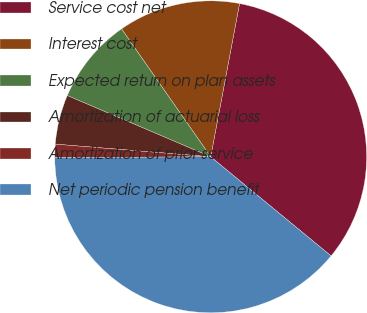Convert chart. <chart><loc_0><loc_0><loc_500><loc_500><pie_chart><fcel>Service cost net<fcel>Interest cost<fcel>Expected return on plan assets<fcel>Amortization of actuarial loss<fcel>Amortization of prior service<fcel>Net periodic pension benefit<nl><fcel>33.0%<fcel>12.65%<fcel>8.89%<fcel>5.13%<fcel>1.37%<fcel>38.96%<nl></chart> 